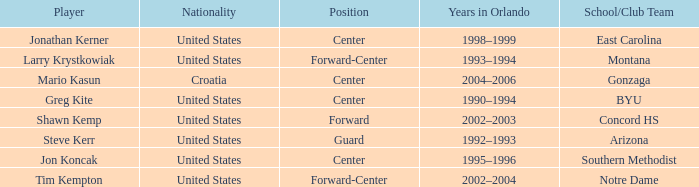What years in Orlando have the United States as the nationality, with concord hs as the school/club team? 2002–2003. 